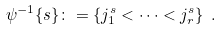Convert formula to latex. <formula><loc_0><loc_0><loc_500><loc_500>\psi ^ { - 1 } \{ s \} \colon = \{ j ^ { s } _ { 1 } < \dots < j ^ { s } _ { r } \} \ .</formula> 